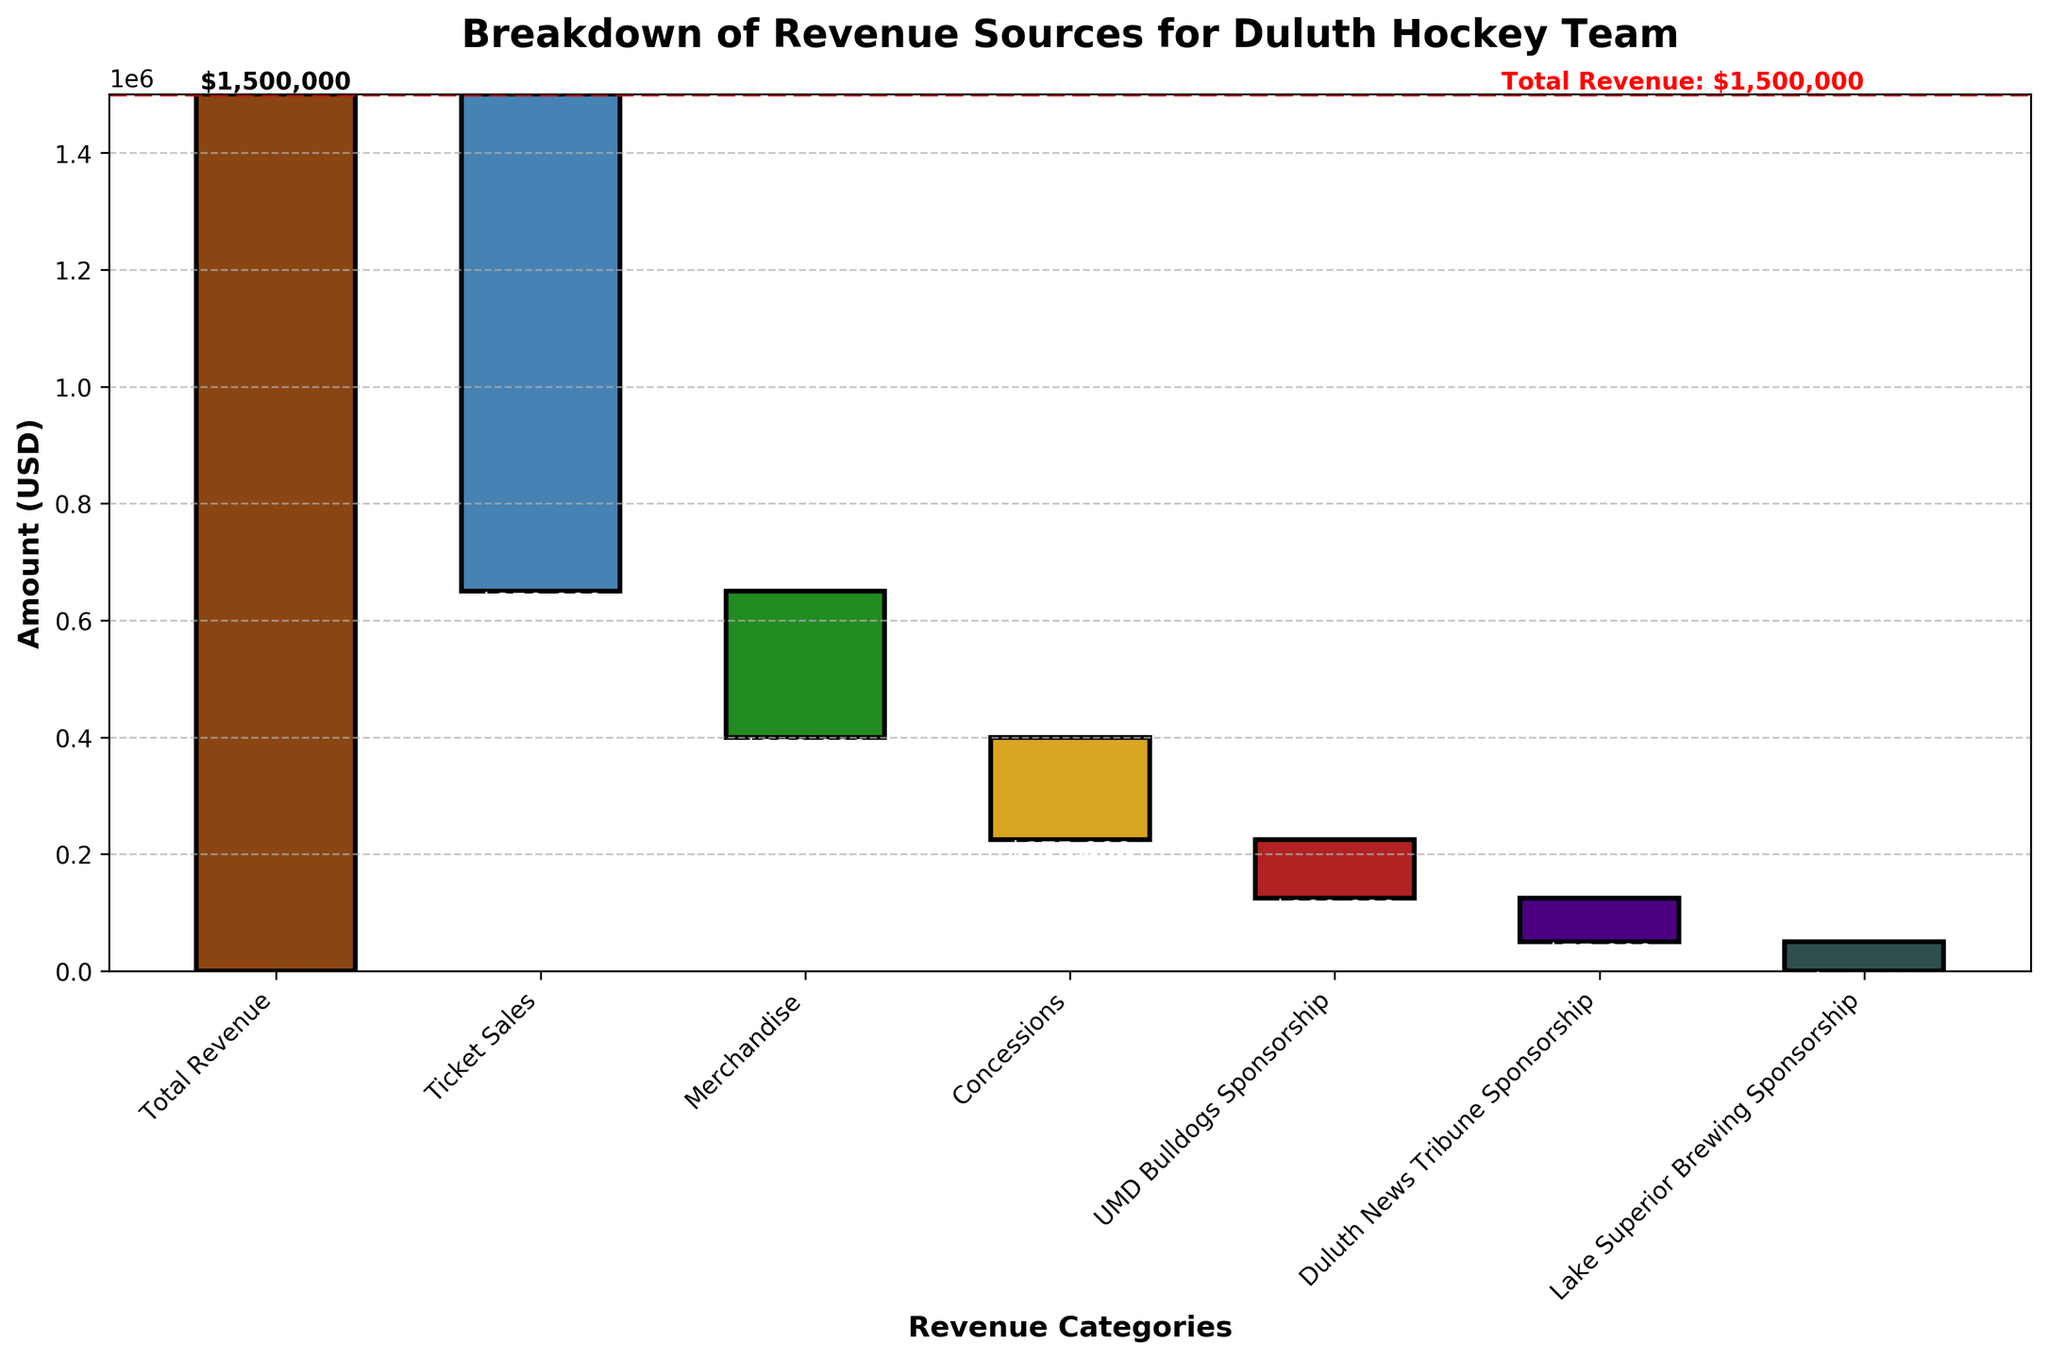What is the total revenue for the Duluth hockey team? The title of the plot indicates it is a breakdown of revenue sources for the Duluth hockey team, and the first bar represents the total revenue with a value of $1,500,000 labeled at the top.
Answer: $1,500,000 How much revenue is generated from ticket sales? The bar representing ticket sales is the first in the breakdown section and is labeled with -$850,000 dollars.
Answer: $850,000 Which revenue source contributes the least amount? By looking at the bars, the smallest value in the breakdown appears to be from Lake Superior Brewing Sponsorship at -$50,000.
Answer: Lake Superior Brewing Sponsorship What is the combined revenue from merchandise and concessions? Add the values for merchandise (-$250,000) and concessions (-$175,000). The combined total is -$250,000 + -$175,000 = -$425,000.
Answer: $425,000 How does the revenue from Duluth News Tribune Sponsorship compare to UMD Bulldogs Sponsorship? The value for Duluth News Tribune Sponsorship is -$75,000 and for UMD Bulldogs Sponsorship it is -$100,000. Duluth News Tribune Sponsorship is $25,000 higher than UMD Bulldogs Sponsorship.
Answer: $25,000 higher What are the different revenue categories displayed in the plot? The x-axis labels display the categories which are Total Revenue, Ticket Sales, Merchandise, Concessions, UMD Bulldogs Sponsorship, Duluth News Tribune Sponsorship, and Lake Superior Brewing Sponsorship.
Answer: Total Revenue, Ticket Sales, Merchandise, Concessions, UMD Bulldogs Sponsorship, Duluth News Tribune Sponsorship, Lake Superior Brewing Sponsorship What is the total sponsorship revenue? Add the values for the three sponsorships: UMD Bulldogs Sponsorship (-$100,000), Duluth News Tribune Sponsorship (-$75,000), and Lake Superior Brewing Sponsorship (-$50,000). The total is -$100,000 + -$75,000 + -$50,000 = -$225,000.
Answer: $225,000 What color is used for the Merchandise bar, and what notable feature does it have? The Merchandise bar is the third one in the sequence, and it's highlighted in green, with -$250,000 visibly marked on it.
Answer: Green 